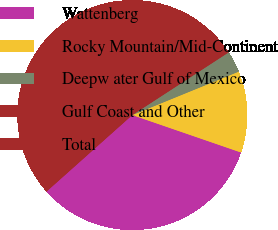Convert chart. <chart><loc_0><loc_0><loc_500><loc_500><pie_chart><fcel>Wattenberg<fcel>Rocky Mountain/Mid-Continent<fcel>Deepw ater Gulf of Mexico<fcel>Gulf Coast and Other<fcel>Total<nl><fcel>33.13%<fcel>11.45%<fcel>3.01%<fcel>7.23%<fcel>45.18%<nl></chart> 